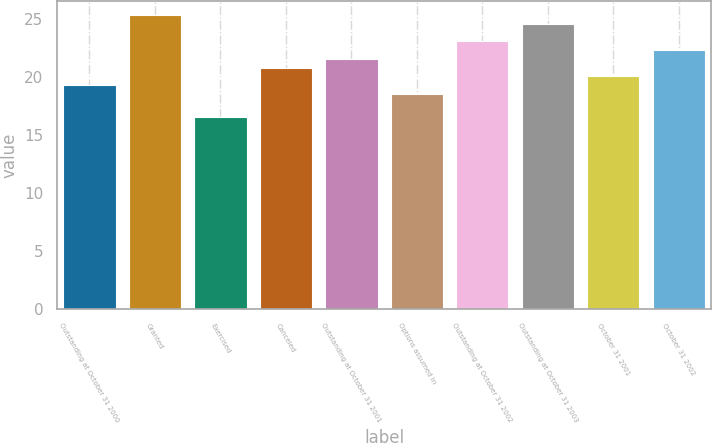Convert chart. <chart><loc_0><loc_0><loc_500><loc_500><bar_chart><fcel>Outstanding at October 31 2000<fcel>Granted<fcel>Exercised<fcel>Canceled<fcel>Outstanding at October 31 2001<fcel>Options assumed in<fcel>Outstanding at October 31 2002<fcel>Outstanding at October 31 2003<fcel>October 31 2001<fcel>October 31 2002<nl><fcel>19.33<fcel>25.33<fcel>16.57<fcel>20.83<fcel>21.58<fcel>18.58<fcel>23.08<fcel>24.58<fcel>20.08<fcel>22.33<nl></chart> 